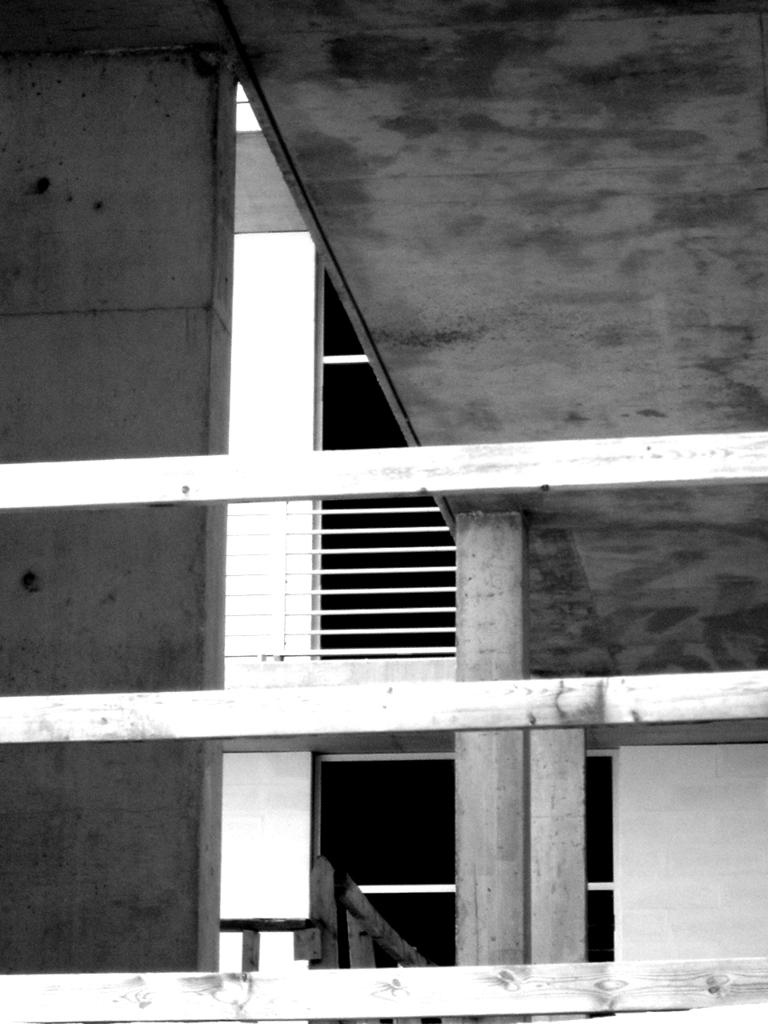What type of structure is visible in the picture? There is a building in the picture. What feature can be seen near the building? There is a railing in the picture. How would you describe the color scheme of the image? The image is black and white. Can you see a mitten hanging on the railing in the image? No, there is no mitten present in the image. Are there any parents visible in the image? There is no reference to parents or any people in the image, so it cannot be determined if they are present. 